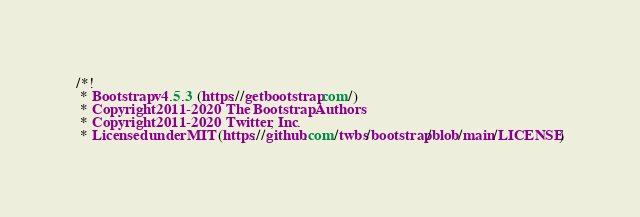Convert code to text. <code><loc_0><loc_0><loc_500><loc_500><_CSS_>/*!
 * Bootstrap v4.5.3 (https://getbootstrap.com/)
 * Copyright 2011-2020 The Bootstrap Authors
 * Copyright 2011-2020 Twitter, Inc.
 * Licensed under MIT (https://github.com/twbs/bootstrap/blob/main/LICENSE)</code> 